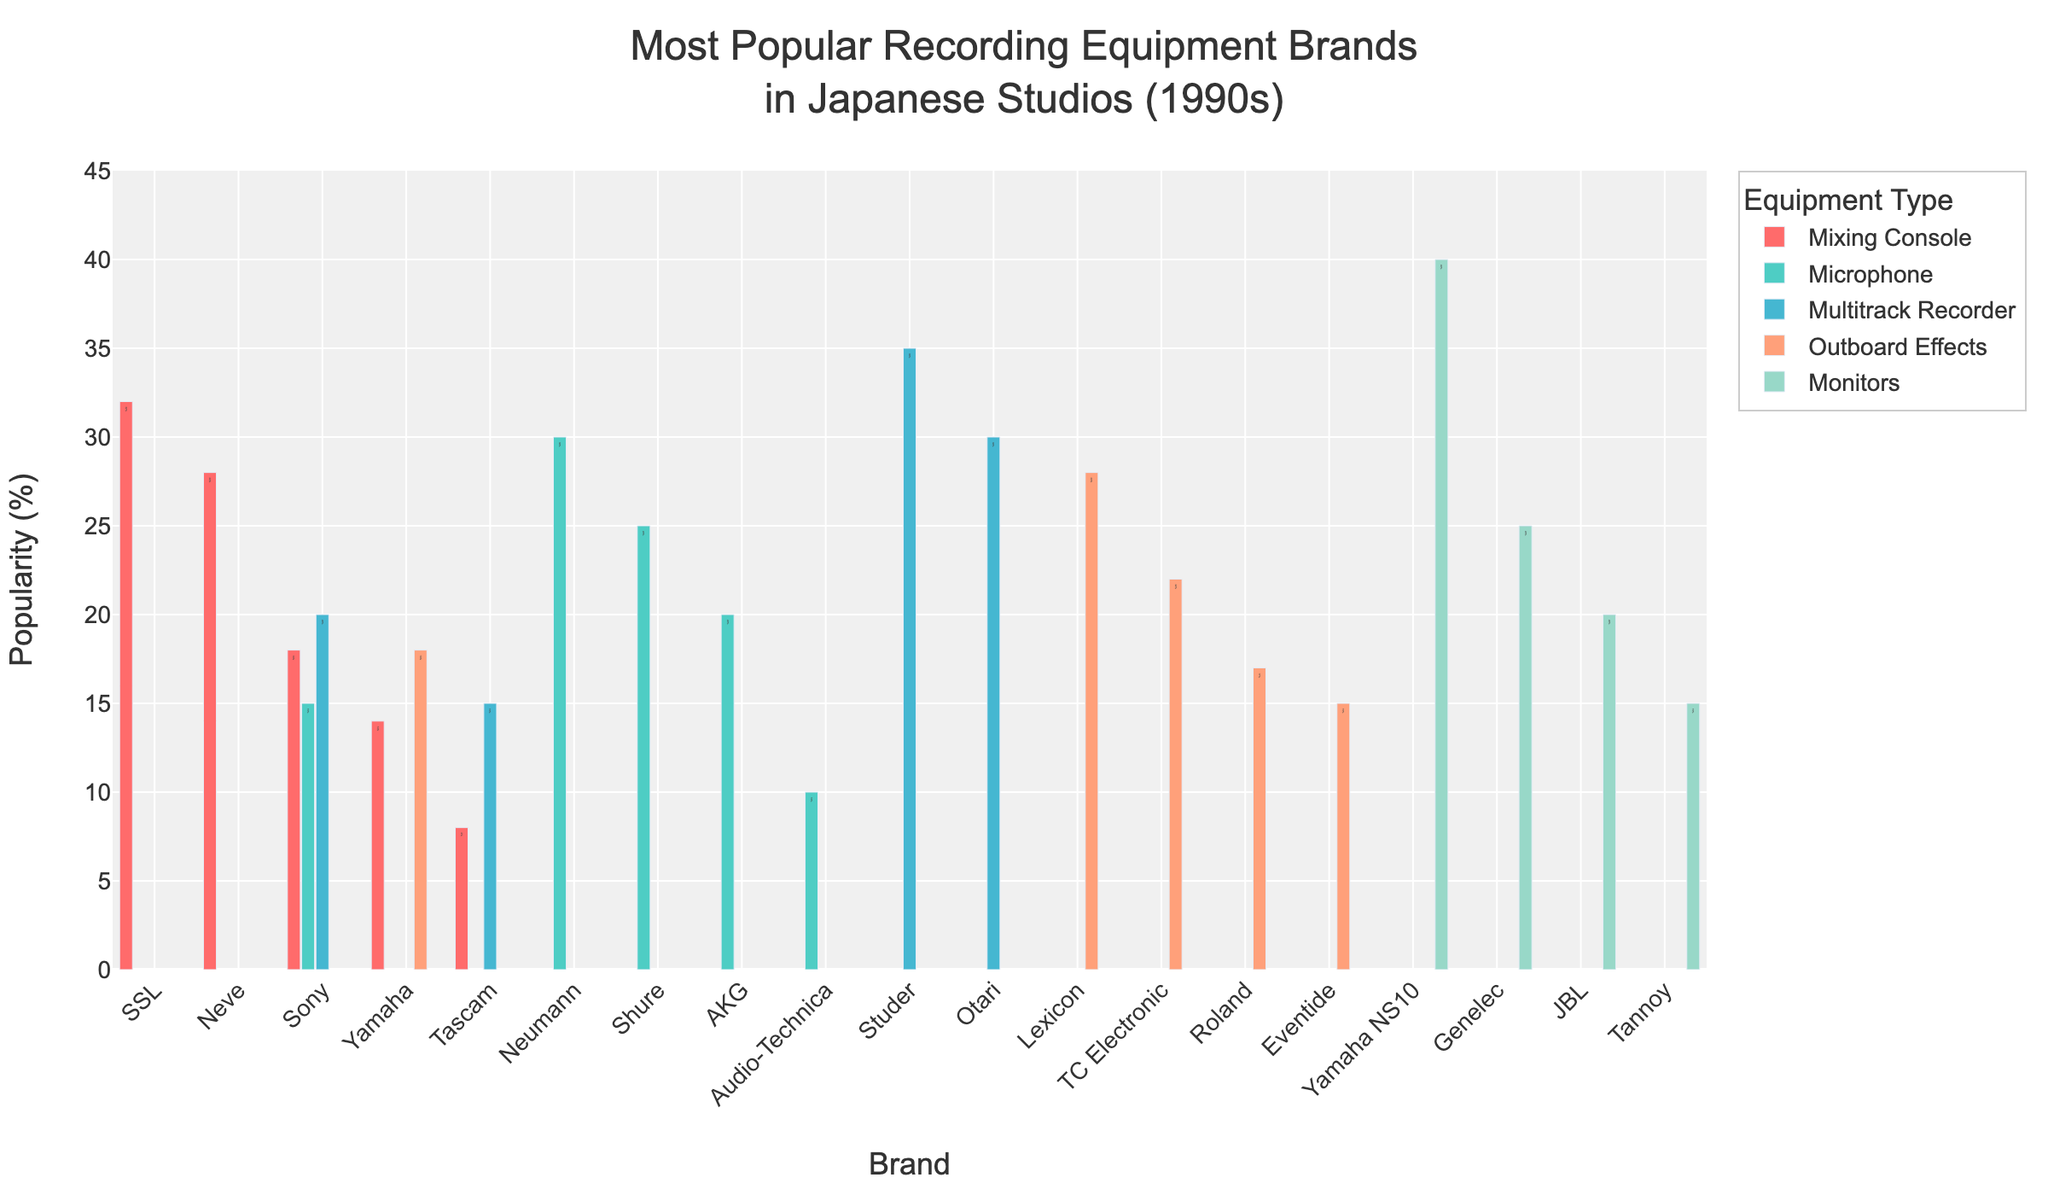What is the most popular brand for mixing consoles and by what percentage is it popular? Look at the Mixing Console category and find the brand with the highest percentage. SSL has the highest popularity at 32%.
Answer: SSL, 32% Which microphone brand is more popular: Neumann or Shure? Compare the percentages of Neumann and Shure in the Microphone category. Neumann is 30% and Shure is 25%. Neumann is more popular.
Answer: Neumann By what percentage is Yamaha NS10 more popular than the least popular brand in the Monitors category? Identify the popularity percentage of Yamaha NS10 (40%) and the least popular brand Tannoy (15%), then calculate the difference: 40% - 15% = 25%.
Answer: 25% Among the Multitrack Recorders, which brand is the least popular and what is its percentage? Check the percentages in the Multitrack Recorder category and find the lowest value. Tascam is the least popular at 15%.
Answer: Tascam, 15% What is the total popularity percentage of the top two brands in the Outboard Effects category? Find the top two percentages in the Outboard Effects category (Lexicon 28%, TC Electronic 22%) and sum them: 28% + 22% = 50%.
Answer: 50% Which category has the highest overall maximum popularity percentage and what is the brand associated with it? Identify the maximum percentage in each category and compare them: Yamaha NS10 in Monitors (40%), SSL in Mixing Console (32%), Neumann in Microphone (30%), Studer in Multitrack Recorder (35%), Lexicon in Outboard Effects (28%). The highest is Monitors with Yamaha NS10 at 40%.
Answer: Monitors, Yamaha NS10 By how much does the popularity of the least popular brand in the Mixing Console category differ from the most popular brand in the Microphone category? Identify the percentages: Tascam in Mixing Console (8%) and Neumann in Microphone (30%), then calculate the difference: 30% - 8% = 22%.
Answer: 22% Which brand has higher popularity, Sony in the Mixing Console category or Sony in the Microphone category? Compare Sony's percentages in the Mixing Console (18%) and Microphone (15%) categories. The Mixing Console category has a higher percentage.
Answer: Mixing Console What is the combined popularity percentage of all brands in the Mixing Console category? Add up the percentages of all brands in the Mixing Console category: 32% (SSL) + 28% (Neve) + 18% (Sony) + 14% (Yamaha) + 8% (Tascam) = 100%.
Answer: 100% Who is the second most popular brand among the Multitrack Recorders and what is its percentage? Identify the second highest percentage in the Multitrack Recorder category. Otari has the second highest popularity at 30%.
Answer: Otari, 30% 